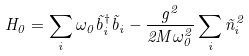<formula> <loc_0><loc_0><loc_500><loc_500>H _ { 0 } = \sum _ { i } \omega _ { 0 } \tilde { b } ^ { \dagger } _ { i } \tilde { b } _ { i } - \frac { g ^ { 2 } } { 2 M \omega _ { 0 } ^ { 2 } } \sum _ { i } \tilde { n } _ { i } ^ { 2 }</formula> 